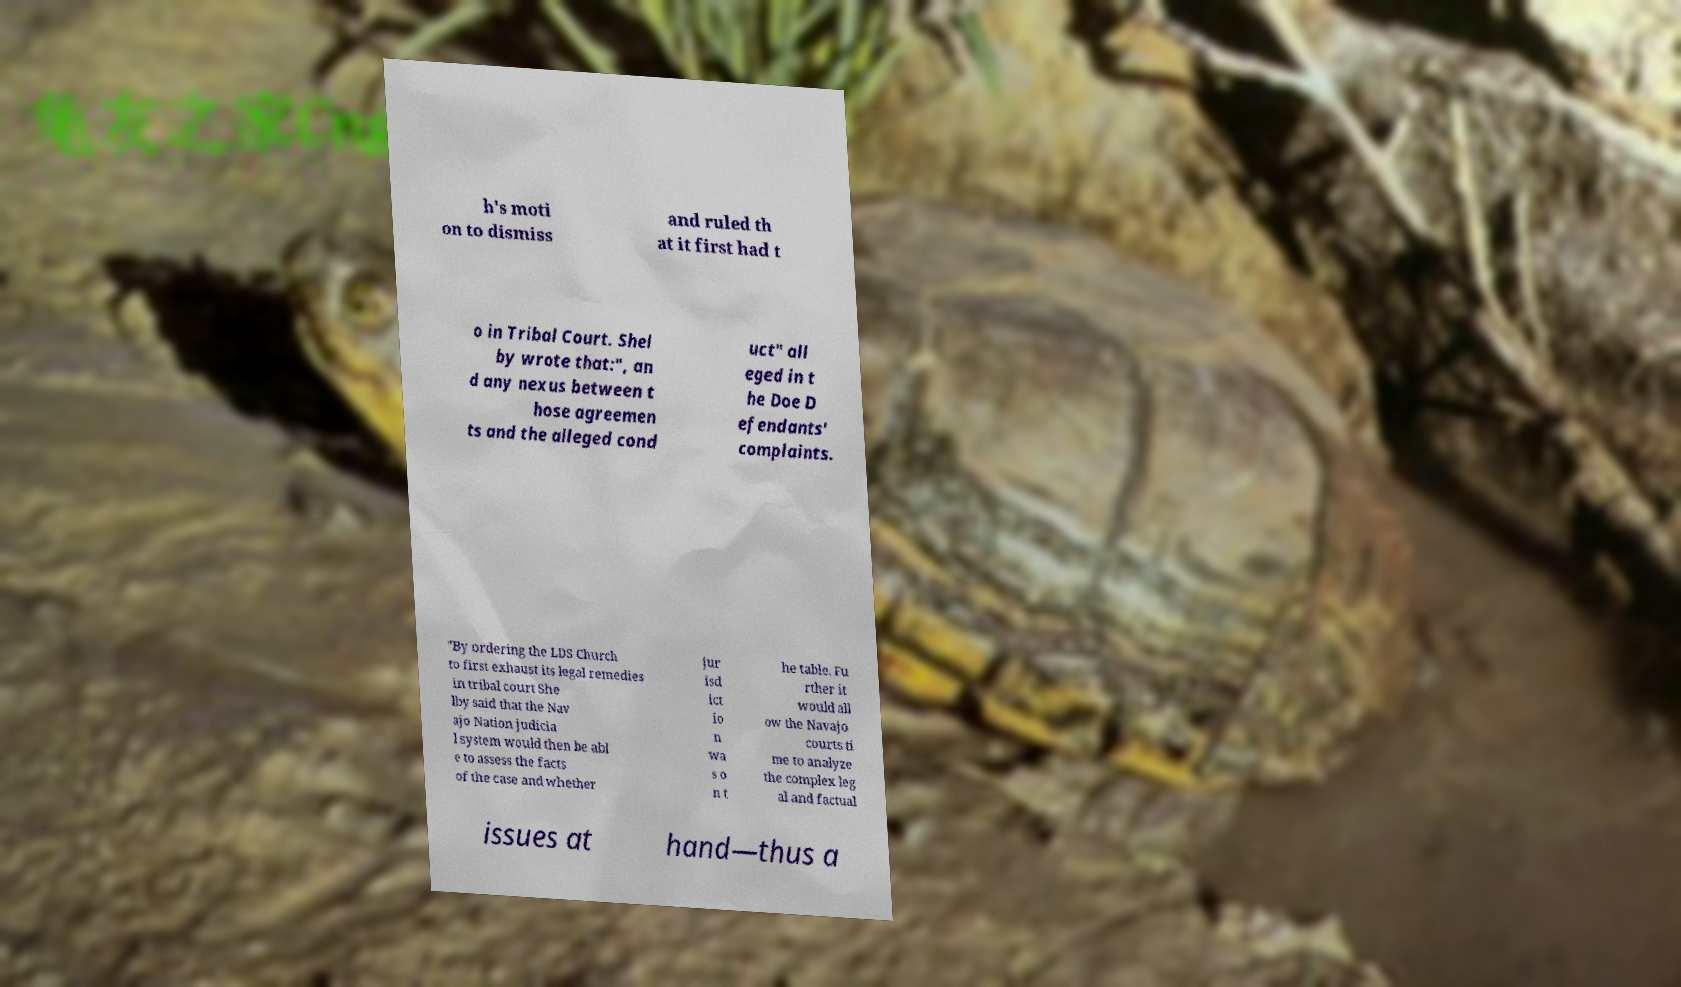Can you read and provide the text displayed in the image?This photo seems to have some interesting text. Can you extract and type it out for me? h's moti on to dismiss and ruled th at it first had t o in Tribal Court. Shel by wrote that:", an d any nexus between t hose agreemen ts and the alleged cond uct" all eged in t he Doe D efendants' complaints. "By ordering the LDS Church to first exhaust its legal remedies in tribal court She lby said that the Nav ajo Nation judicia l system would then be abl e to assess the facts of the case and whether jur isd ict io n wa s o n t he table. Fu rther it would all ow the Navajo courts ti me to analyze the complex leg al and factual issues at hand—thus a 